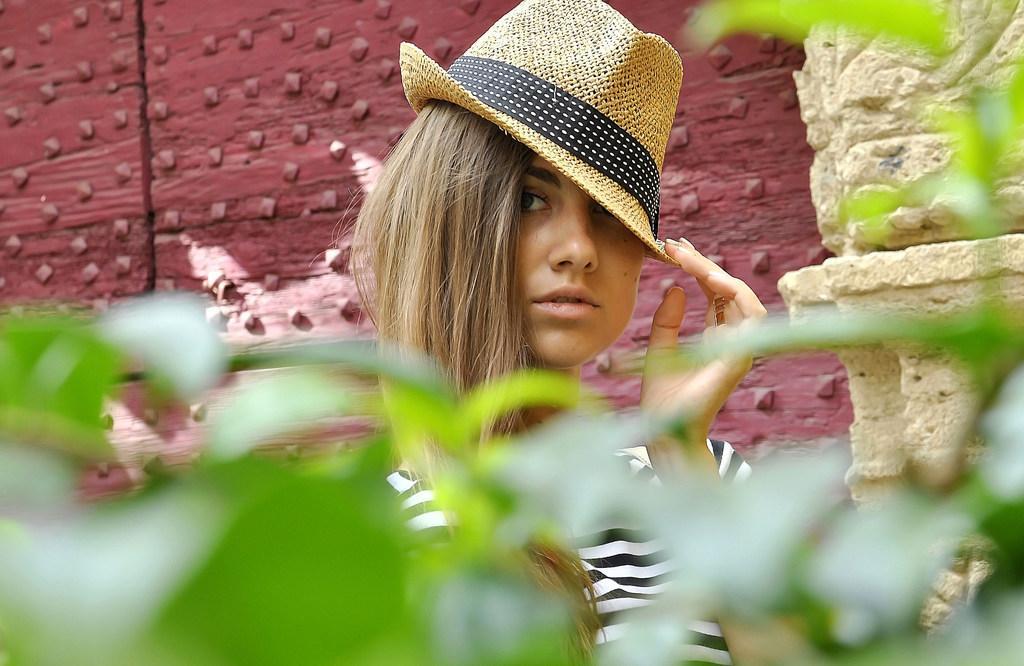Describe this image in one or two sentences. In this image we can see a woman. She is wearing a hat and T-shirt. Behind her, we can see the wall. At the bottom of the image, we can see leaves. 